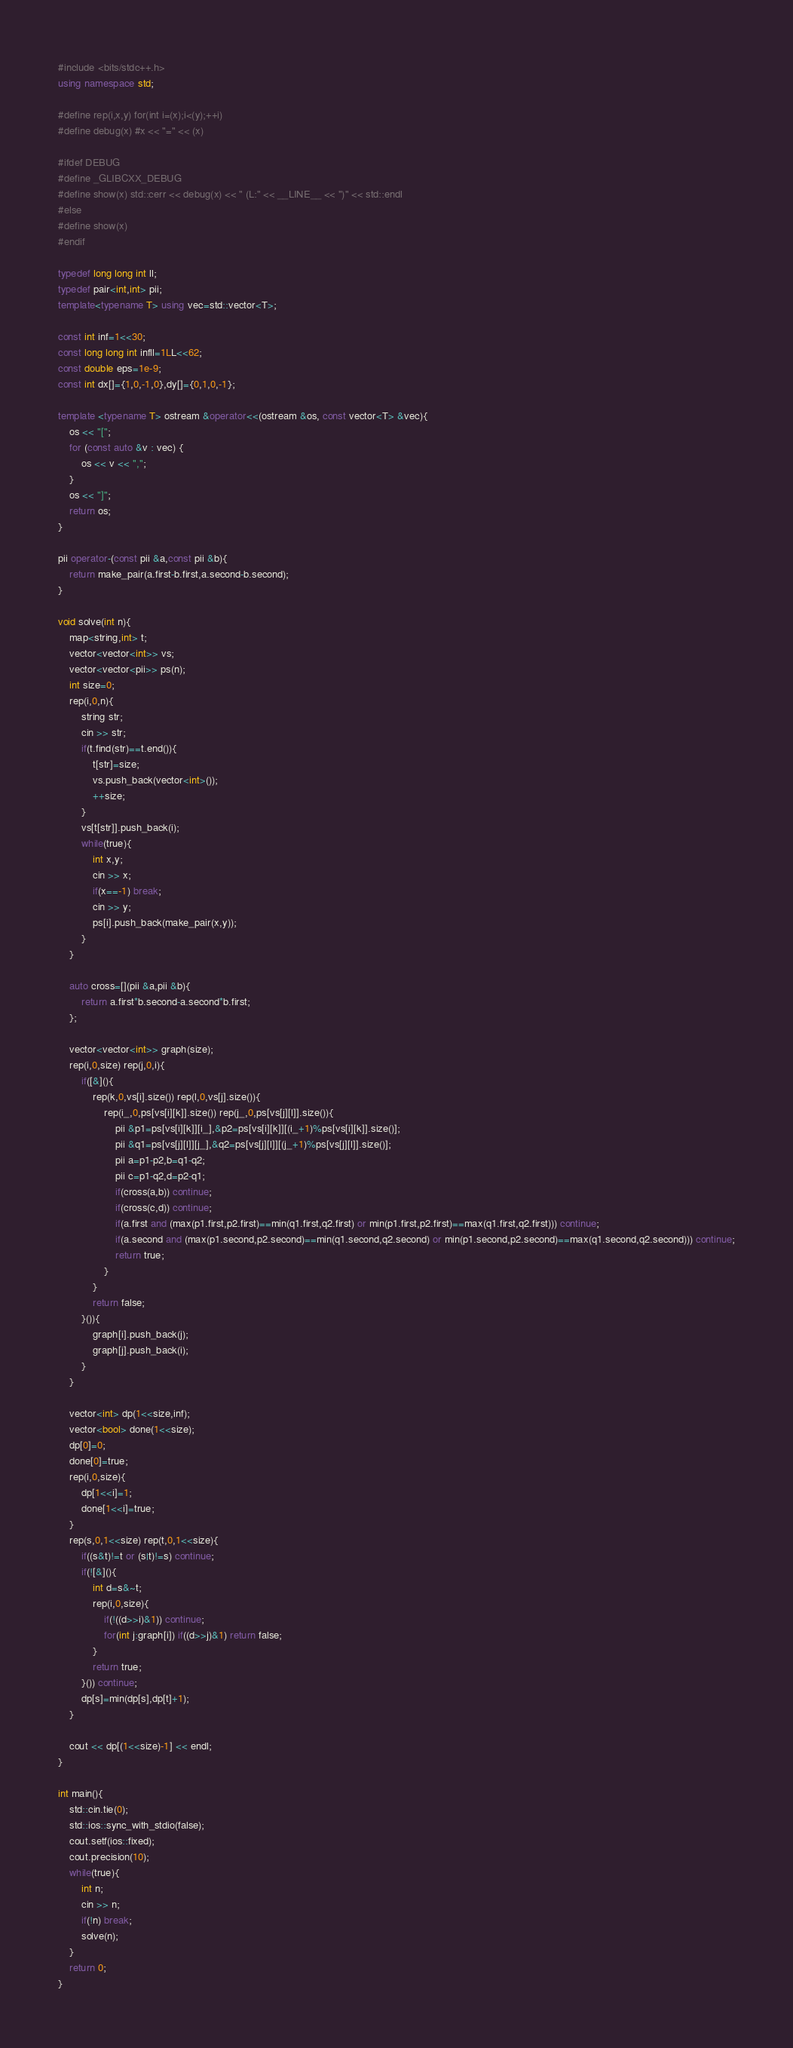<code> <loc_0><loc_0><loc_500><loc_500><_C++_>#include <bits/stdc++.h>
using namespace std;

#define rep(i,x,y) for(int i=(x);i<(y);++i)
#define debug(x) #x << "=" << (x)

#ifdef DEBUG
#define _GLIBCXX_DEBUG
#define show(x) std::cerr << debug(x) << " (L:" << __LINE__ << ")" << std::endl
#else
#define show(x)
#endif

typedef long long int ll;
typedef pair<int,int> pii;
template<typename T> using vec=std::vector<T>;

const int inf=1<<30;
const long long int infll=1LL<<62;
const double eps=1e-9;
const int dx[]={1,0,-1,0},dy[]={0,1,0,-1};

template <typename T> ostream &operator<<(ostream &os, const vector<T> &vec){
    os << "[";
    for (const auto &v : vec) {
    	os << v << ",";
    }
    os << "]";
    return os;
}

pii operator-(const pii &a,const pii &b){
    return make_pair(a.first-b.first,a.second-b.second);
}

void solve(int n){
    map<string,int> t;
    vector<vector<int>> vs;
    vector<vector<pii>> ps(n);
    int size=0;
    rep(i,0,n){
        string str;
        cin >> str;
        if(t.find(str)==t.end()){
            t[str]=size;
            vs.push_back(vector<int>());
            ++size;
        }
        vs[t[str]].push_back(i);
        while(true){
            int x,y;
            cin >> x;
            if(x==-1) break;
            cin >> y;
            ps[i].push_back(make_pair(x,y));
        }
    }

    auto cross=[](pii &a,pii &b){
        return a.first*b.second-a.second*b.first;
    };

    vector<vector<int>> graph(size);
    rep(i,0,size) rep(j,0,i){
        if([&](){
            rep(k,0,vs[i].size()) rep(l,0,vs[j].size()){
                rep(i_,0,ps[vs[i][k]].size()) rep(j_,0,ps[vs[j][l]].size()){
                    pii &p1=ps[vs[i][k]][i_],&p2=ps[vs[i][k]][(i_+1)%ps[vs[i][k]].size()];
                    pii &q1=ps[vs[j][l]][j_],&q2=ps[vs[j][l]][(j_+1)%ps[vs[j][l]].size()];
                    pii a=p1-p2,b=q1-q2;
                    pii c=p1-q2,d=p2-q1;
                    if(cross(a,b)) continue;
                    if(cross(c,d)) continue;
                    if(a.first and (max(p1.first,p2.first)==min(q1.first,q2.first) or min(p1.first,p2.first)==max(q1.first,q2.first))) continue;
                    if(a.second and (max(p1.second,p2.second)==min(q1.second,q2.second) or min(p1.second,p2.second)==max(q1.second,q2.second))) continue;
                    return true;
                }
            }
            return false;
        }()){
            graph[i].push_back(j);
            graph[j].push_back(i);
        }
    }

    vector<int> dp(1<<size,inf);
    vector<bool> done(1<<size);
    dp[0]=0;
    done[0]=true;
    rep(i,0,size){
        dp[1<<i]=1;
        done[1<<i]=true;
    }
    rep(s,0,1<<size) rep(t,0,1<<size){
        if((s&t)!=t or (s|t)!=s) continue;
        if(![&](){
            int d=s&~t;
            rep(i,0,size){
                if(!((d>>i)&1)) continue;
                for(int j:graph[i]) if((d>>j)&1) return false;
            }
            return true;
        }()) continue;
        dp[s]=min(dp[s],dp[t]+1);
    }

    cout << dp[(1<<size)-1] << endl;
}

int main(){
    std::cin.tie(0);
    std::ios::sync_with_stdio(false);
    cout.setf(ios::fixed);
    cout.precision(10);
    while(true){
        int n;
        cin >> n;
        if(!n) break;
        solve(n);
    }
    return 0;
}</code> 